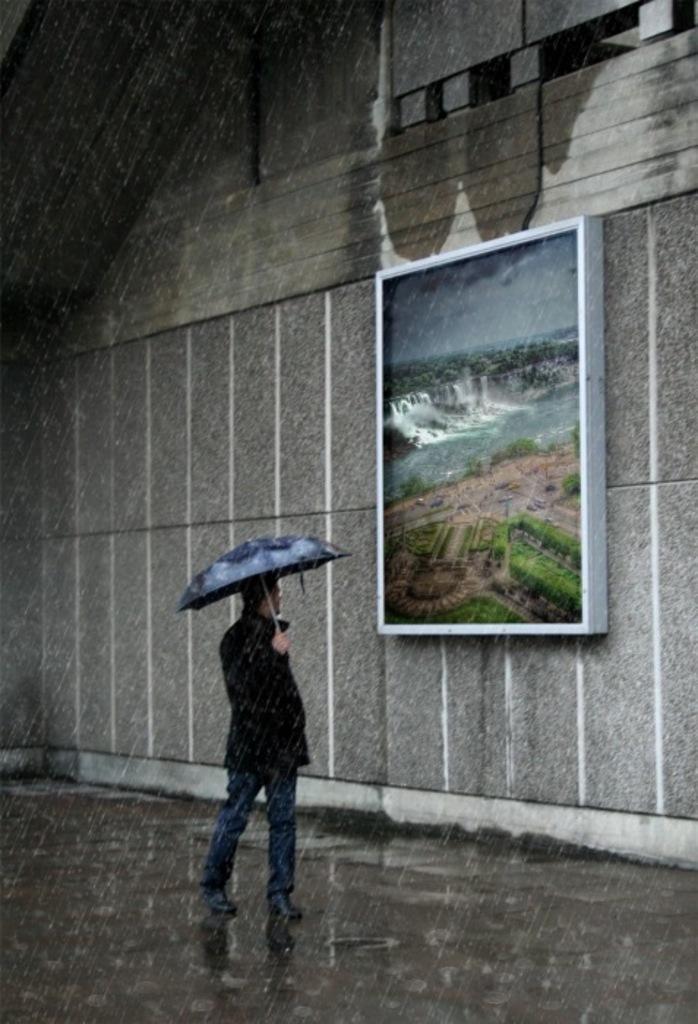Can you describe this image briefly? In the center of the image we can see a man standing and holding an umbrella. In the background there is a board placed on the wall. At the bottom there is water. 